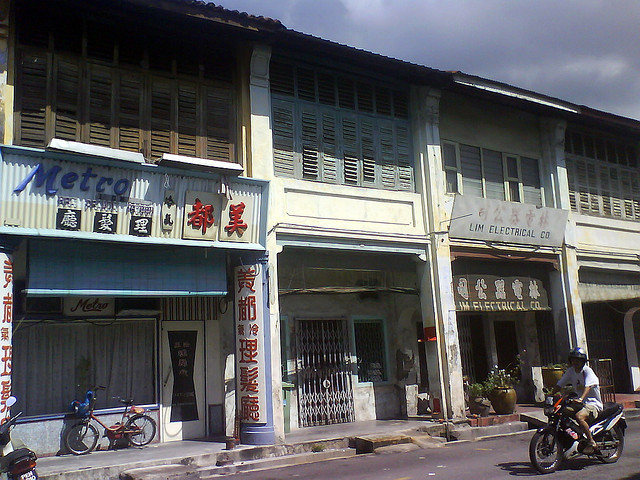<image>What state is pictured somewhere on the building? I don't know what state is pictured on the building. It can be Ohio, China, Massachusetts. But I am not sure. What state is pictured somewhere on the building? I am not sure if any state is pictured on the building. There is no clear indication of a specific state. 